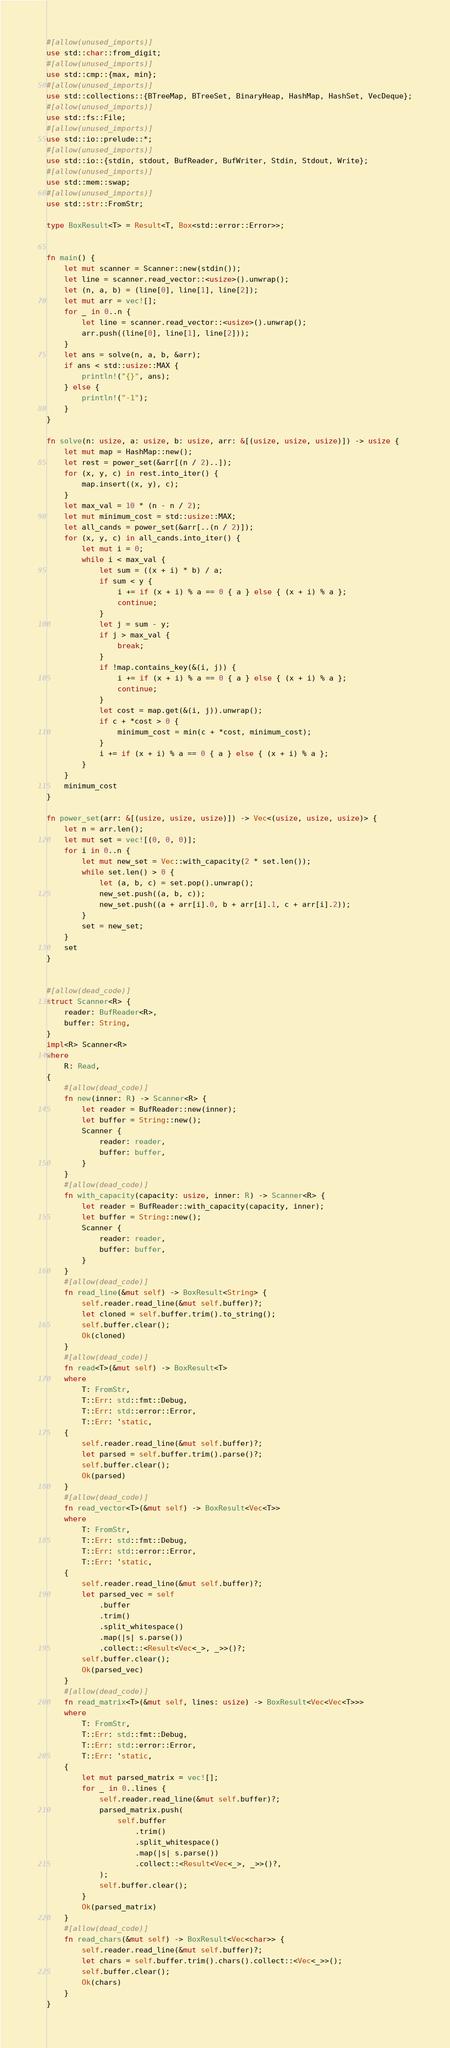Convert code to text. <code><loc_0><loc_0><loc_500><loc_500><_Rust_>#[allow(unused_imports)]
use std::char::from_digit;
#[allow(unused_imports)]
use std::cmp::{max, min};
#[allow(unused_imports)]
use std::collections::{BTreeMap, BTreeSet, BinaryHeap, HashMap, HashSet, VecDeque};
#[allow(unused_imports)]
use std::fs::File;
#[allow(unused_imports)]
use std::io::prelude::*;
#[allow(unused_imports)]
use std::io::{stdin, stdout, BufReader, BufWriter, Stdin, Stdout, Write};
#[allow(unused_imports)]
use std::mem::swap;
#[allow(unused_imports)]
use std::str::FromStr;

type BoxResult<T> = Result<T, Box<std::error::Error>>;


fn main() {
    let mut scanner = Scanner::new(stdin());
    let line = scanner.read_vector::<usize>().unwrap();
    let (n, a, b) = (line[0], line[1], line[2]);
    let mut arr = vec![];
    for _ in 0..n {
        let line = scanner.read_vector::<usize>().unwrap();
        arr.push((line[0], line[1], line[2]));
    }
    let ans = solve(n, a, b, &arr);
    if ans < std::usize::MAX {
        println!("{}", ans);
    } else {
        println!("-1");
    }
}

fn solve(n: usize, a: usize, b: usize, arr: &[(usize, usize, usize)]) -> usize {
    let mut map = HashMap::new();
    let rest = power_set(&arr[(n / 2)..]);
    for (x, y, c) in rest.into_iter() {
        map.insert((x, y), c);
    }
    let max_val = 10 * (n - n / 2);
    let mut minimum_cost = std::usize::MAX;
    let all_cands = power_set(&arr[..(n / 2)]);
    for (x, y, c) in all_cands.into_iter() {
        let mut i = 0;
        while i < max_val {
            let sum = ((x + i) * b) / a;
            if sum < y {
                i += if (x + i) % a == 0 { a } else { (x + i) % a };
                continue;
            }
            let j = sum - y;
            if j > max_val {
                break;
            }
            if !map.contains_key(&(i, j)) {
                i += if (x + i) % a == 0 { a } else { (x + i) % a };
                continue;
            }
            let cost = map.get(&(i, j)).unwrap();
            if c + *cost > 0 {
                minimum_cost = min(c + *cost, minimum_cost);
            }
            i += if (x + i) % a == 0 { a } else { (x + i) % a };
        }
    }
    minimum_cost
}

fn power_set(arr: &[(usize, usize, usize)]) -> Vec<(usize, usize, usize)> {
    let n = arr.len();
    let mut set = vec![(0, 0, 0)];
    for i in 0..n {
        let mut new_set = Vec::with_capacity(2 * set.len());
        while set.len() > 0 {
            let (a, b, c) = set.pop().unwrap();
            new_set.push((a, b, c));
            new_set.push((a + arr[i].0, b + arr[i].1, c + arr[i].2));
        }
        set = new_set;
    }
    set
}


#[allow(dead_code)]
struct Scanner<R> {
    reader: BufReader<R>,
    buffer: String,
}
impl<R> Scanner<R>
where
    R: Read,
{
    #[allow(dead_code)]
    fn new(inner: R) -> Scanner<R> {
        let reader = BufReader::new(inner);
        let buffer = String::new();
        Scanner {
            reader: reader,
            buffer: buffer,
        }
    }
    #[allow(dead_code)]
    fn with_capacity(capacity: usize, inner: R) -> Scanner<R> {
        let reader = BufReader::with_capacity(capacity, inner);
        let buffer = String::new();
        Scanner {
            reader: reader,
            buffer: buffer,
        }
    }
    #[allow(dead_code)]
    fn read_line(&mut self) -> BoxResult<String> {
        self.reader.read_line(&mut self.buffer)?;
        let cloned = self.buffer.trim().to_string();
        self.buffer.clear();
        Ok(cloned)
    }
    #[allow(dead_code)]
    fn read<T>(&mut self) -> BoxResult<T>
    where
        T: FromStr,
        T::Err: std::fmt::Debug,
        T::Err: std::error::Error,
        T::Err: 'static,
    {
        self.reader.read_line(&mut self.buffer)?;
        let parsed = self.buffer.trim().parse()?;
        self.buffer.clear();
        Ok(parsed)
    }
    #[allow(dead_code)]
    fn read_vector<T>(&mut self) -> BoxResult<Vec<T>>
    where
        T: FromStr,
        T::Err: std::fmt::Debug,
        T::Err: std::error::Error,
        T::Err: 'static,
    {
        self.reader.read_line(&mut self.buffer)?;
        let parsed_vec = self
            .buffer
            .trim()
            .split_whitespace()
            .map(|s| s.parse())
            .collect::<Result<Vec<_>, _>>()?;
        self.buffer.clear();
        Ok(parsed_vec)
    }
    #[allow(dead_code)]
    fn read_matrix<T>(&mut self, lines: usize) -> BoxResult<Vec<Vec<T>>>
    where
        T: FromStr,
        T::Err: std::fmt::Debug,
        T::Err: std::error::Error,
        T::Err: 'static,
    {
        let mut parsed_matrix = vec![];
        for _ in 0..lines {
            self.reader.read_line(&mut self.buffer)?;
            parsed_matrix.push(
                self.buffer
                    .trim()
                    .split_whitespace()
                    .map(|s| s.parse())
                    .collect::<Result<Vec<_>, _>>()?,
            );
            self.buffer.clear();
        }
        Ok(parsed_matrix)
    }
    #[allow(dead_code)]
    fn read_chars(&mut self) -> BoxResult<Vec<char>> {
        self.reader.read_line(&mut self.buffer)?;
        let chars = self.buffer.trim().chars().collect::<Vec<_>>();
        self.buffer.clear();
        Ok(chars)
    }
}
</code> 